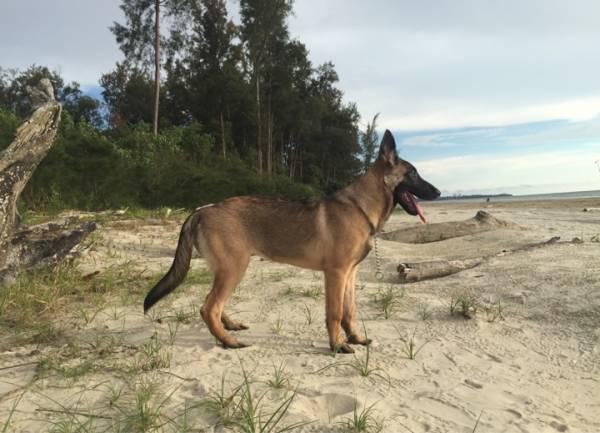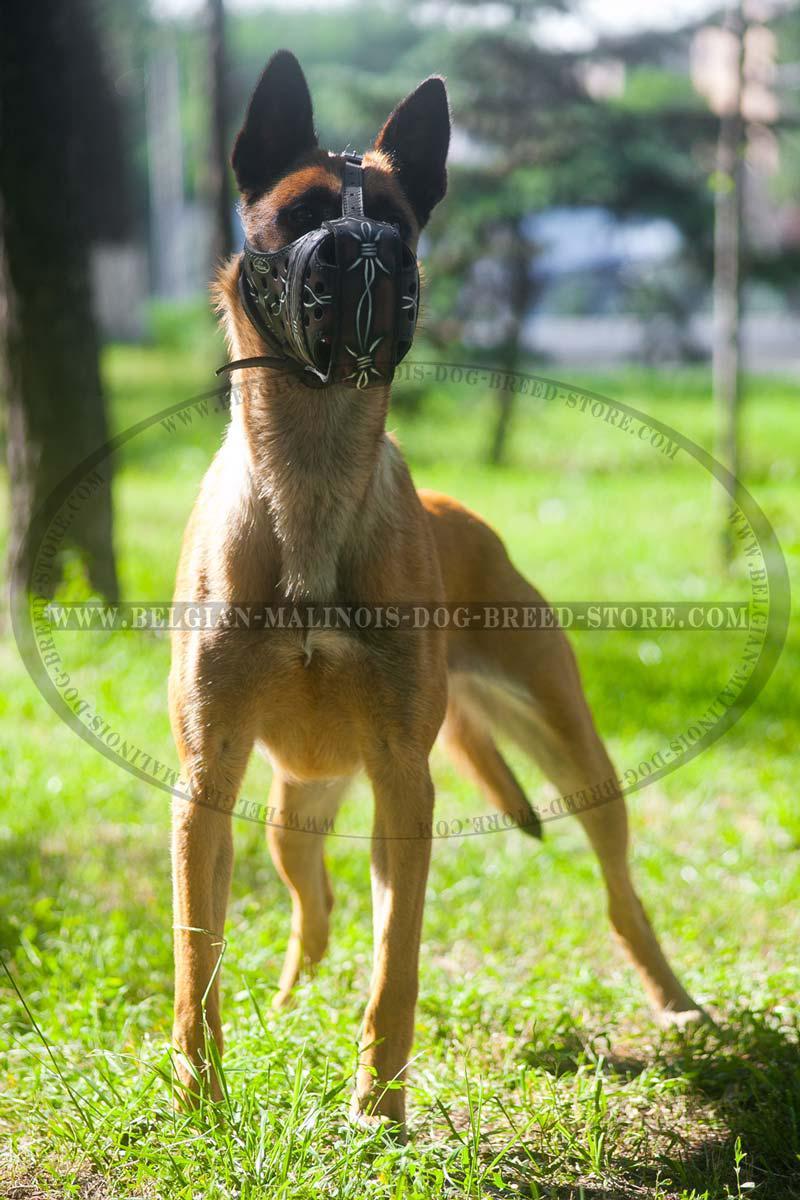The first image is the image on the left, the second image is the image on the right. Assess this claim about the two images: "At least one leash is visible in both images.". Correct or not? Answer yes or no. No. The first image is the image on the left, the second image is the image on the right. Considering the images on both sides, is "One german shepherd is standing and the other german shepherd is posed with its front paws extended; at least one dog wears a collar and leash but no dog wears a muzzle." valid? Answer yes or no. No. 